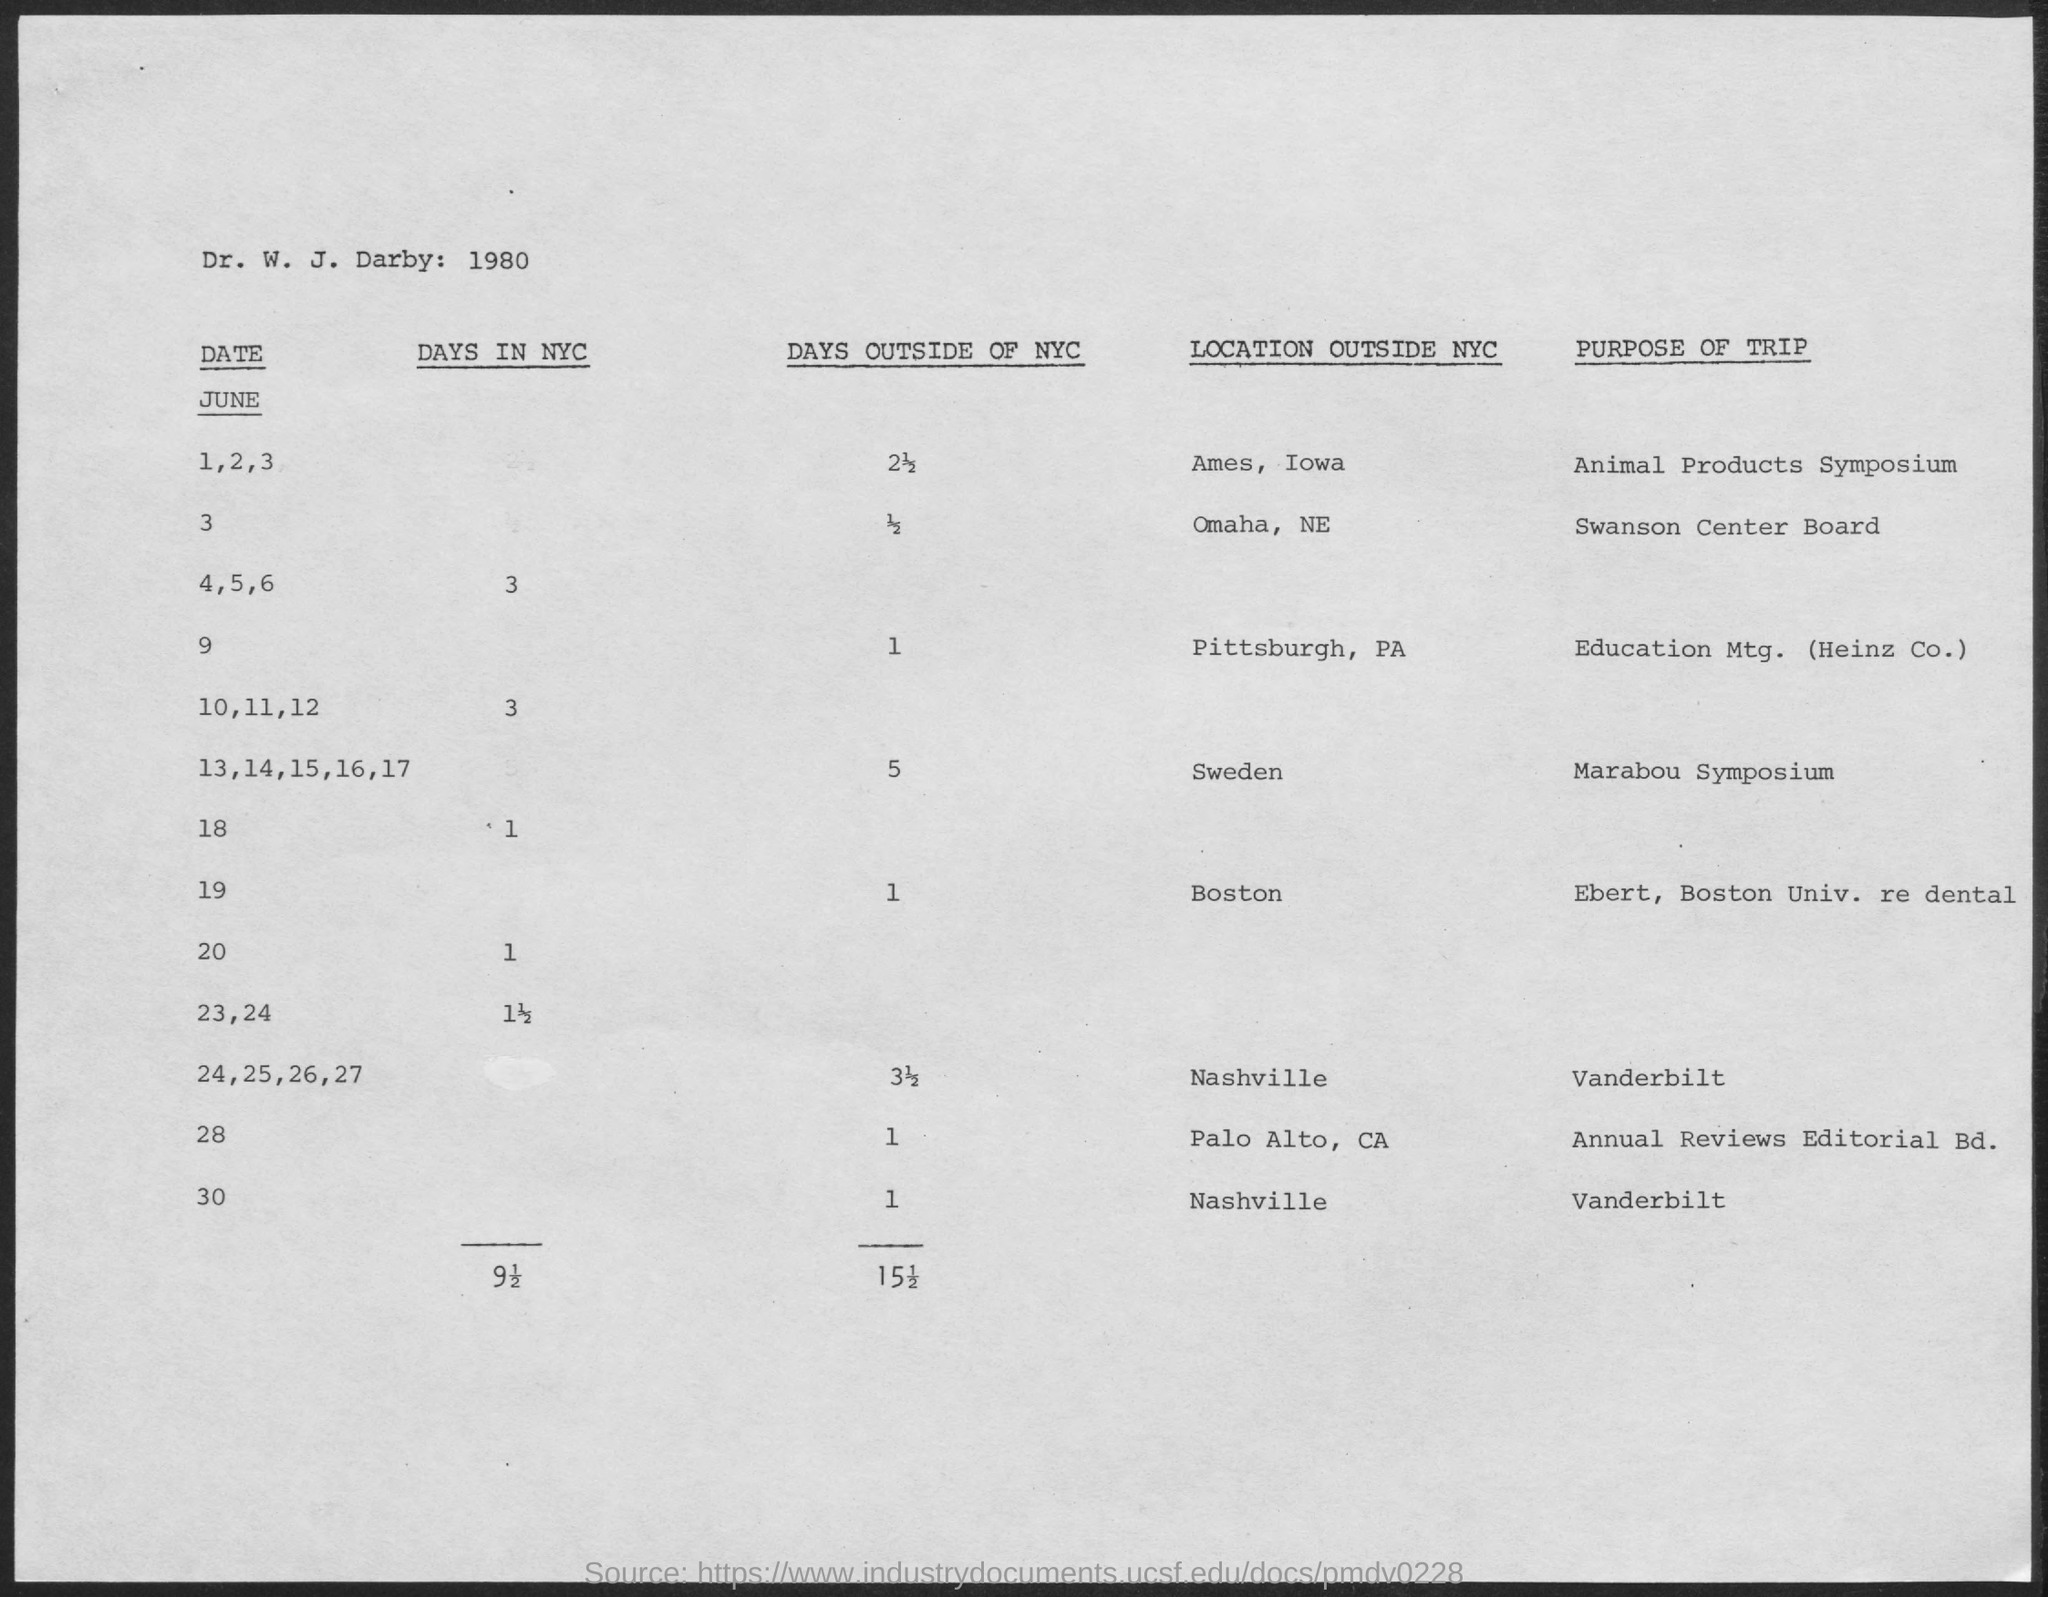What is the purpose of trip on June 1,2,3?
Offer a very short reply. Animal Products Symposium. Where is the Marabou Symposium going to be held?
Provide a short and direct response. Sweden. 